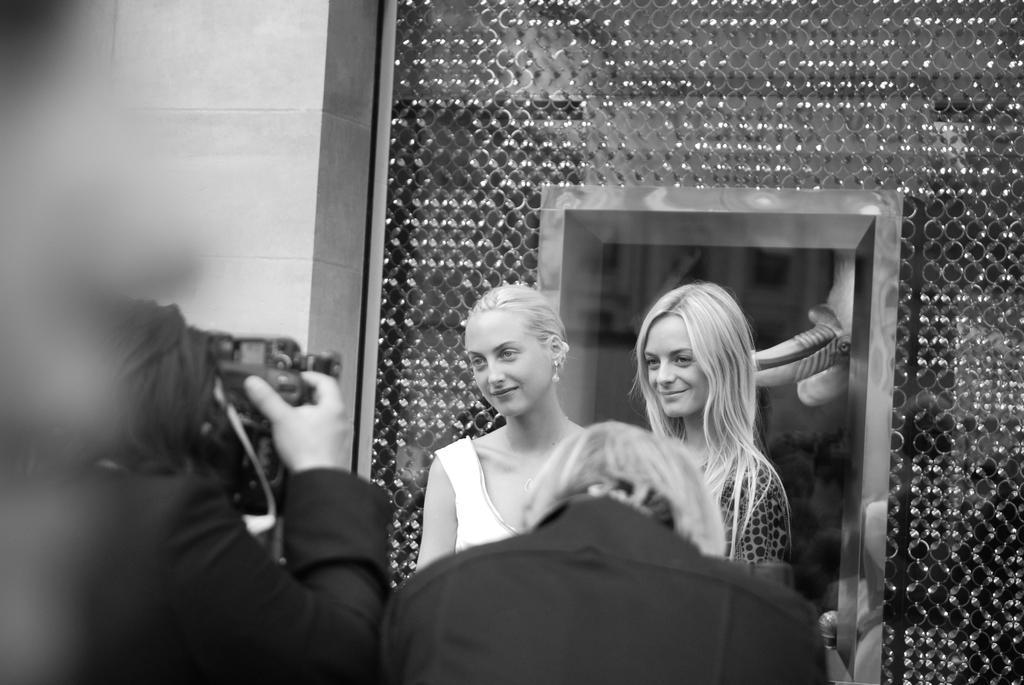Can you describe this image briefly? This is a black and white image, we can see a few people, and a few are holding some objects, we can see the wall with some objects. 